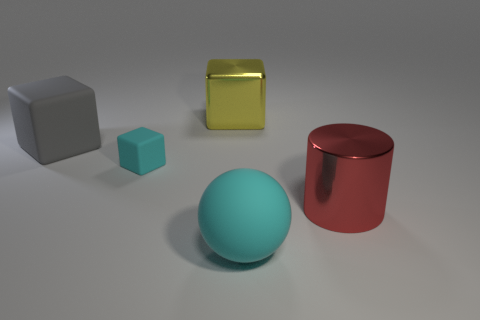How many things are large matte objects or large metallic cylinders? In the image, there are two large matte objects, a gray cube and a turquoise cube, along with one large metallic cylinder, which is the red cylindrical object. So there are a total of three objects fitting the description. 